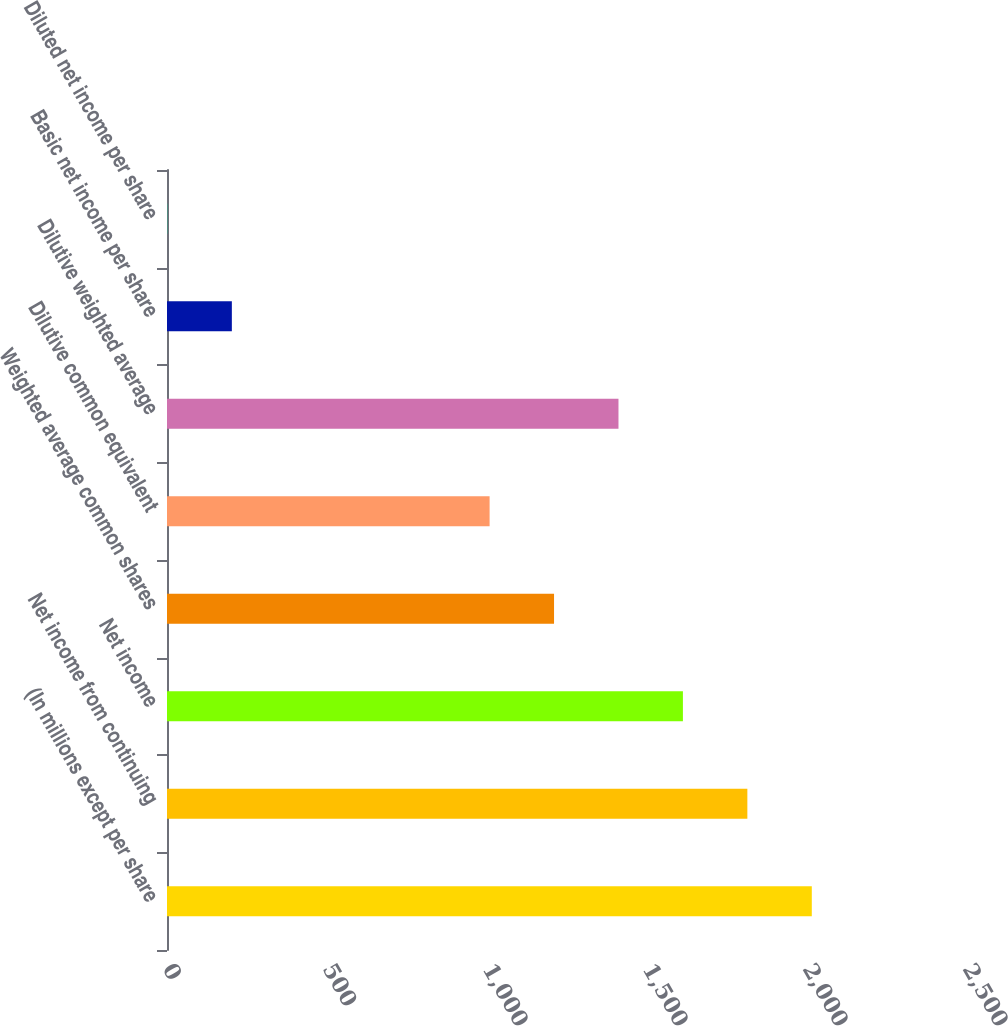Convert chart. <chart><loc_0><loc_0><loc_500><loc_500><bar_chart><fcel>(In millions except per share<fcel>Net income from continuing<fcel>Net income<fcel>Weighted average common shares<fcel>Dilutive common equivalent<fcel>Dilutive weighted average<fcel>Basic net income per share<fcel>Diluted net income per share<nl><fcel>2015<fcel>1813.61<fcel>1612.24<fcel>1209.5<fcel>1008.13<fcel>1410.87<fcel>202.65<fcel>1.28<nl></chart> 